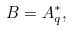Convert formula to latex. <formula><loc_0><loc_0><loc_500><loc_500>B = A _ { q } ^ { * } ,</formula> 